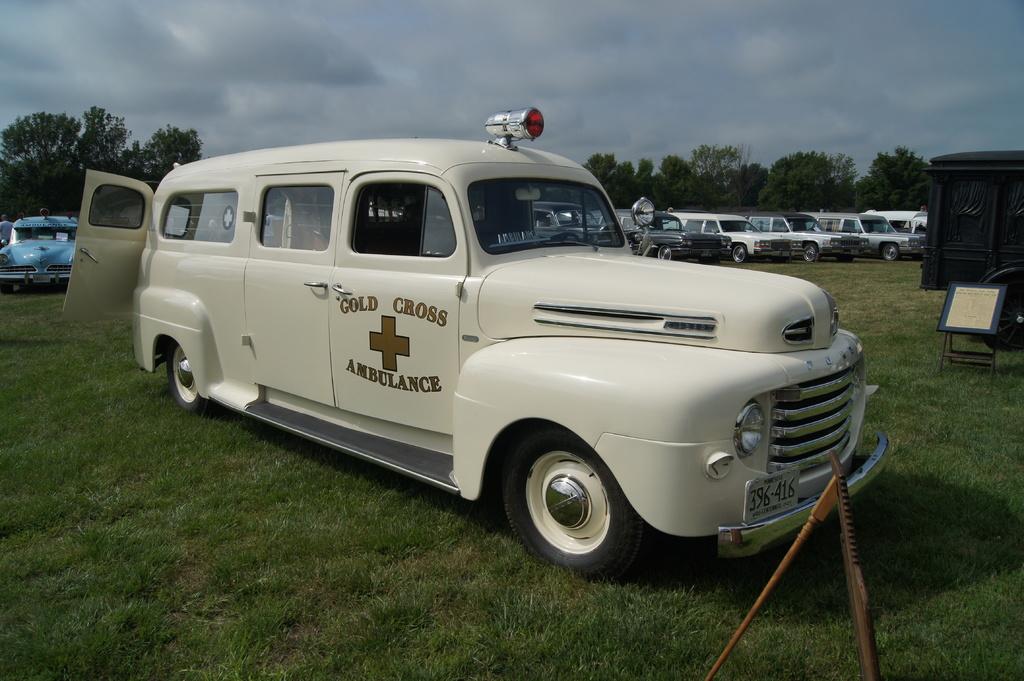What kind of vehicle is this?
Keep it short and to the point. Ambulance. What is the license plate number of this vehicle?
Keep it short and to the point. 396-416. 